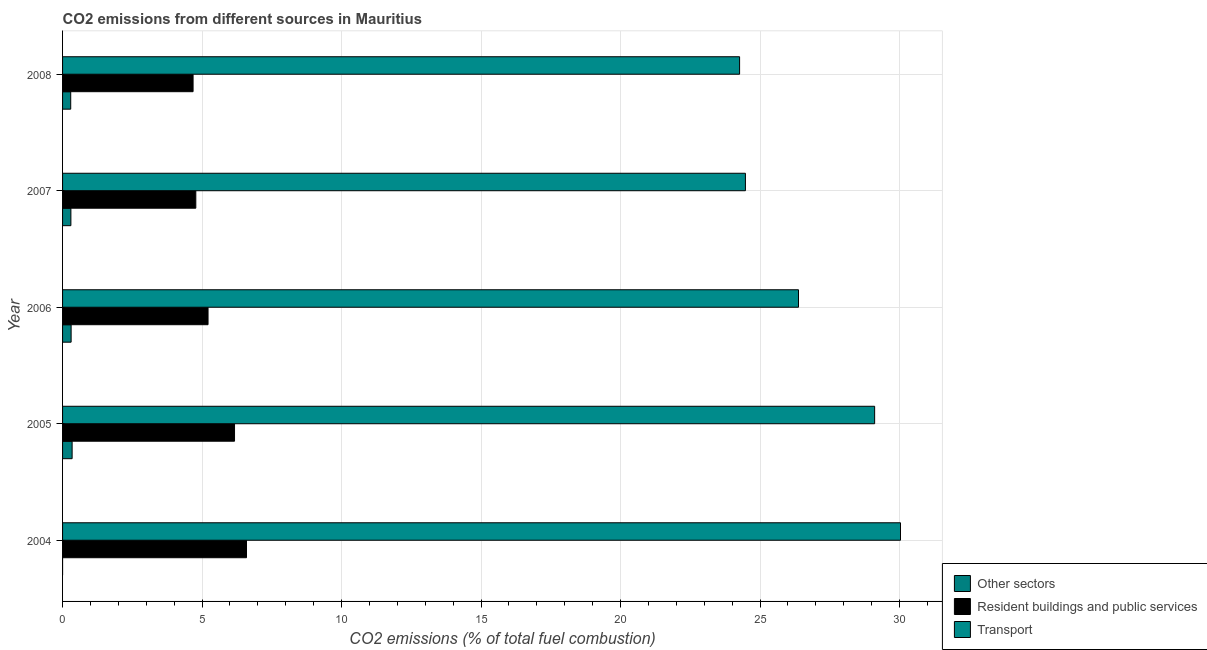How many different coloured bars are there?
Ensure brevity in your answer.  3. Are the number of bars per tick equal to the number of legend labels?
Ensure brevity in your answer.  No. Are the number of bars on each tick of the Y-axis equal?
Offer a very short reply. No. What is the label of the 2nd group of bars from the top?
Keep it short and to the point. 2007. What is the percentage of co2 emissions from transport in 2005?
Your answer should be very brief. 29.11. Across all years, what is the maximum percentage of co2 emissions from transport?
Provide a succinct answer. 30.04. What is the total percentage of co2 emissions from other sectors in the graph?
Your answer should be compact. 1.24. What is the difference between the percentage of co2 emissions from other sectors in 2007 and that in 2008?
Provide a short and direct response. 0.01. What is the difference between the percentage of co2 emissions from resident buildings and public services in 2006 and the percentage of co2 emissions from other sectors in 2005?
Your answer should be compact. 4.87. What is the average percentage of co2 emissions from other sectors per year?
Ensure brevity in your answer.  0.25. In the year 2005, what is the difference between the percentage of co2 emissions from resident buildings and public services and percentage of co2 emissions from other sectors?
Provide a succinct answer. 5.82. In how many years, is the percentage of co2 emissions from other sectors greater than 30 %?
Offer a very short reply. 0. What is the ratio of the percentage of co2 emissions from resident buildings and public services in 2004 to that in 2006?
Your answer should be very brief. 1.26. Is the difference between the percentage of co2 emissions from resident buildings and public services in 2006 and 2008 greater than the difference between the percentage of co2 emissions from transport in 2006 and 2008?
Your answer should be compact. No. What is the difference between the highest and the second highest percentage of co2 emissions from resident buildings and public services?
Offer a very short reply. 0.43. What is the difference between the highest and the lowest percentage of co2 emissions from resident buildings and public services?
Provide a short and direct response. 1.92. In how many years, is the percentage of co2 emissions from transport greater than the average percentage of co2 emissions from transport taken over all years?
Keep it short and to the point. 2. Is it the case that in every year, the sum of the percentage of co2 emissions from other sectors and percentage of co2 emissions from resident buildings and public services is greater than the percentage of co2 emissions from transport?
Make the answer very short. No. Are all the bars in the graph horizontal?
Provide a succinct answer. Yes. What is the difference between two consecutive major ticks on the X-axis?
Provide a short and direct response. 5. Where does the legend appear in the graph?
Provide a short and direct response. Bottom right. How many legend labels are there?
Your answer should be very brief. 3. What is the title of the graph?
Make the answer very short. CO2 emissions from different sources in Mauritius. Does "Hydroelectric sources" appear as one of the legend labels in the graph?
Provide a succinct answer. No. What is the label or title of the X-axis?
Provide a short and direct response. CO2 emissions (% of total fuel combustion). What is the CO2 emissions (% of total fuel combustion) in Resident buildings and public services in 2004?
Give a very brief answer. 6.59. What is the CO2 emissions (% of total fuel combustion) of Transport in 2004?
Your answer should be compact. 30.04. What is the CO2 emissions (% of total fuel combustion) of Other sectors in 2005?
Your answer should be very brief. 0.34. What is the CO2 emissions (% of total fuel combustion) of Resident buildings and public services in 2005?
Provide a short and direct response. 6.16. What is the CO2 emissions (% of total fuel combustion) of Transport in 2005?
Make the answer very short. 29.11. What is the CO2 emissions (% of total fuel combustion) of Other sectors in 2006?
Ensure brevity in your answer.  0.31. What is the CO2 emissions (% of total fuel combustion) in Resident buildings and public services in 2006?
Your response must be concise. 5.21. What is the CO2 emissions (% of total fuel combustion) of Transport in 2006?
Ensure brevity in your answer.  26.38. What is the CO2 emissions (% of total fuel combustion) of Other sectors in 2007?
Provide a short and direct response. 0.3. What is the CO2 emissions (% of total fuel combustion) of Resident buildings and public services in 2007?
Your answer should be very brief. 4.78. What is the CO2 emissions (% of total fuel combustion) in Transport in 2007?
Your answer should be compact. 24.48. What is the CO2 emissions (% of total fuel combustion) of Other sectors in 2008?
Ensure brevity in your answer.  0.29. What is the CO2 emissions (% of total fuel combustion) of Resident buildings and public services in 2008?
Your response must be concise. 4.68. What is the CO2 emissions (% of total fuel combustion) of Transport in 2008?
Make the answer very short. 24.27. Across all years, what is the maximum CO2 emissions (% of total fuel combustion) in Other sectors?
Your answer should be very brief. 0.34. Across all years, what is the maximum CO2 emissions (% of total fuel combustion) in Resident buildings and public services?
Make the answer very short. 6.59. Across all years, what is the maximum CO2 emissions (% of total fuel combustion) in Transport?
Offer a terse response. 30.04. Across all years, what is the minimum CO2 emissions (% of total fuel combustion) in Resident buildings and public services?
Your answer should be compact. 4.68. Across all years, what is the minimum CO2 emissions (% of total fuel combustion) of Transport?
Keep it short and to the point. 24.27. What is the total CO2 emissions (% of total fuel combustion) of Other sectors in the graph?
Offer a terse response. 1.24. What is the total CO2 emissions (% of total fuel combustion) of Resident buildings and public services in the graph?
Your answer should be very brief. 27.43. What is the total CO2 emissions (% of total fuel combustion) in Transport in the graph?
Provide a succinct answer. 134.27. What is the difference between the CO2 emissions (% of total fuel combustion) of Resident buildings and public services in 2004 and that in 2005?
Provide a succinct answer. 0.43. What is the difference between the CO2 emissions (% of total fuel combustion) in Transport in 2004 and that in 2005?
Provide a succinct answer. 0.93. What is the difference between the CO2 emissions (% of total fuel combustion) in Resident buildings and public services in 2004 and that in 2006?
Provide a succinct answer. 1.38. What is the difference between the CO2 emissions (% of total fuel combustion) of Transport in 2004 and that in 2006?
Provide a short and direct response. 3.66. What is the difference between the CO2 emissions (% of total fuel combustion) of Resident buildings and public services in 2004 and that in 2007?
Provide a short and direct response. 1.82. What is the difference between the CO2 emissions (% of total fuel combustion) of Transport in 2004 and that in 2007?
Give a very brief answer. 5.56. What is the difference between the CO2 emissions (% of total fuel combustion) in Resident buildings and public services in 2004 and that in 2008?
Offer a very short reply. 1.92. What is the difference between the CO2 emissions (% of total fuel combustion) of Transport in 2004 and that in 2008?
Keep it short and to the point. 5.77. What is the difference between the CO2 emissions (% of total fuel combustion) of Other sectors in 2005 and that in 2006?
Make the answer very short. 0.04. What is the difference between the CO2 emissions (% of total fuel combustion) in Resident buildings and public services in 2005 and that in 2006?
Make the answer very short. 0.95. What is the difference between the CO2 emissions (% of total fuel combustion) of Transport in 2005 and that in 2006?
Your response must be concise. 2.73. What is the difference between the CO2 emissions (% of total fuel combustion) of Other sectors in 2005 and that in 2007?
Your answer should be compact. 0.04. What is the difference between the CO2 emissions (% of total fuel combustion) in Resident buildings and public services in 2005 and that in 2007?
Ensure brevity in your answer.  1.39. What is the difference between the CO2 emissions (% of total fuel combustion) of Transport in 2005 and that in 2007?
Ensure brevity in your answer.  4.63. What is the difference between the CO2 emissions (% of total fuel combustion) in Other sectors in 2005 and that in 2008?
Offer a terse response. 0.05. What is the difference between the CO2 emissions (% of total fuel combustion) of Resident buildings and public services in 2005 and that in 2008?
Give a very brief answer. 1.49. What is the difference between the CO2 emissions (% of total fuel combustion) in Transport in 2005 and that in 2008?
Provide a succinct answer. 4.84. What is the difference between the CO2 emissions (% of total fuel combustion) in Other sectors in 2006 and that in 2007?
Keep it short and to the point. 0.01. What is the difference between the CO2 emissions (% of total fuel combustion) of Resident buildings and public services in 2006 and that in 2007?
Offer a very short reply. 0.44. What is the difference between the CO2 emissions (% of total fuel combustion) of Transport in 2006 and that in 2007?
Offer a very short reply. 1.9. What is the difference between the CO2 emissions (% of total fuel combustion) in Other sectors in 2006 and that in 2008?
Ensure brevity in your answer.  0.01. What is the difference between the CO2 emissions (% of total fuel combustion) of Resident buildings and public services in 2006 and that in 2008?
Your answer should be very brief. 0.54. What is the difference between the CO2 emissions (% of total fuel combustion) in Transport in 2006 and that in 2008?
Give a very brief answer. 2.11. What is the difference between the CO2 emissions (% of total fuel combustion) of Other sectors in 2007 and that in 2008?
Provide a short and direct response. 0.01. What is the difference between the CO2 emissions (% of total fuel combustion) in Resident buildings and public services in 2007 and that in 2008?
Offer a very short reply. 0.1. What is the difference between the CO2 emissions (% of total fuel combustion) of Transport in 2007 and that in 2008?
Offer a very short reply. 0.21. What is the difference between the CO2 emissions (% of total fuel combustion) in Resident buildings and public services in 2004 and the CO2 emissions (% of total fuel combustion) in Transport in 2005?
Ensure brevity in your answer.  -22.52. What is the difference between the CO2 emissions (% of total fuel combustion) of Resident buildings and public services in 2004 and the CO2 emissions (% of total fuel combustion) of Transport in 2006?
Offer a terse response. -19.79. What is the difference between the CO2 emissions (% of total fuel combustion) of Resident buildings and public services in 2004 and the CO2 emissions (% of total fuel combustion) of Transport in 2007?
Your answer should be compact. -17.88. What is the difference between the CO2 emissions (% of total fuel combustion) of Resident buildings and public services in 2004 and the CO2 emissions (% of total fuel combustion) of Transport in 2008?
Offer a terse response. -17.68. What is the difference between the CO2 emissions (% of total fuel combustion) in Other sectors in 2005 and the CO2 emissions (% of total fuel combustion) in Resident buildings and public services in 2006?
Make the answer very short. -4.87. What is the difference between the CO2 emissions (% of total fuel combustion) of Other sectors in 2005 and the CO2 emissions (% of total fuel combustion) of Transport in 2006?
Offer a terse response. -26.04. What is the difference between the CO2 emissions (% of total fuel combustion) of Resident buildings and public services in 2005 and the CO2 emissions (% of total fuel combustion) of Transport in 2006?
Provide a succinct answer. -20.22. What is the difference between the CO2 emissions (% of total fuel combustion) in Other sectors in 2005 and the CO2 emissions (% of total fuel combustion) in Resident buildings and public services in 2007?
Ensure brevity in your answer.  -4.43. What is the difference between the CO2 emissions (% of total fuel combustion) in Other sectors in 2005 and the CO2 emissions (% of total fuel combustion) in Transport in 2007?
Keep it short and to the point. -24.14. What is the difference between the CO2 emissions (% of total fuel combustion) of Resident buildings and public services in 2005 and the CO2 emissions (% of total fuel combustion) of Transport in 2007?
Offer a terse response. -18.31. What is the difference between the CO2 emissions (% of total fuel combustion) of Other sectors in 2005 and the CO2 emissions (% of total fuel combustion) of Resident buildings and public services in 2008?
Ensure brevity in your answer.  -4.34. What is the difference between the CO2 emissions (% of total fuel combustion) of Other sectors in 2005 and the CO2 emissions (% of total fuel combustion) of Transport in 2008?
Make the answer very short. -23.93. What is the difference between the CO2 emissions (% of total fuel combustion) in Resident buildings and public services in 2005 and the CO2 emissions (% of total fuel combustion) in Transport in 2008?
Provide a short and direct response. -18.1. What is the difference between the CO2 emissions (% of total fuel combustion) in Other sectors in 2006 and the CO2 emissions (% of total fuel combustion) in Resident buildings and public services in 2007?
Provide a succinct answer. -4.47. What is the difference between the CO2 emissions (% of total fuel combustion) of Other sectors in 2006 and the CO2 emissions (% of total fuel combustion) of Transport in 2007?
Make the answer very short. -24.17. What is the difference between the CO2 emissions (% of total fuel combustion) in Resident buildings and public services in 2006 and the CO2 emissions (% of total fuel combustion) in Transport in 2007?
Give a very brief answer. -19.26. What is the difference between the CO2 emissions (% of total fuel combustion) in Other sectors in 2006 and the CO2 emissions (% of total fuel combustion) in Resident buildings and public services in 2008?
Your answer should be compact. -4.37. What is the difference between the CO2 emissions (% of total fuel combustion) in Other sectors in 2006 and the CO2 emissions (% of total fuel combustion) in Transport in 2008?
Keep it short and to the point. -23.96. What is the difference between the CO2 emissions (% of total fuel combustion) in Resident buildings and public services in 2006 and the CO2 emissions (% of total fuel combustion) in Transport in 2008?
Offer a very short reply. -19.05. What is the difference between the CO2 emissions (% of total fuel combustion) of Other sectors in 2007 and the CO2 emissions (% of total fuel combustion) of Resident buildings and public services in 2008?
Offer a terse response. -4.38. What is the difference between the CO2 emissions (% of total fuel combustion) in Other sectors in 2007 and the CO2 emissions (% of total fuel combustion) in Transport in 2008?
Keep it short and to the point. -23.97. What is the difference between the CO2 emissions (% of total fuel combustion) in Resident buildings and public services in 2007 and the CO2 emissions (% of total fuel combustion) in Transport in 2008?
Give a very brief answer. -19.49. What is the average CO2 emissions (% of total fuel combustion) of Other sectors per year?
Your response must be concise. 0.25. What is the average CO2 emissions (% of total fuel combustion) of Resident buildings and public services per year?
Your answer should be compact. 5.49. What is the average CO2 emissions (% of total fuel combustion) of Transport per year?
Give a very brief answer. 26.85. In the year 2004, what is the difference between the CO2 emissions (% of total fuel combustion) in Resident buildings and public services and CO2 emissions (% of total fuel combustion) in Transport?
Give a very brief answer. -23.44. In the year 2005, what is the difference between the CO2 emissions (% of total fuel combustion) of Other sectors and CO2 emissions (% of total fuel combustion) of Resident buildings and public services?
Your answer should be compact. -5.82. In the year 2005, what is the difference between the CO2 emissions (% of total fuel combustion) of Other sectors and CO2 emissions (% of total fuel combustion) of Transport?
Provide a succinct answer. -28.77. In the year 2005, what is the difference between the CO2 emissions (% of total fuel combustion) in Resident buildings and public services and CO2 emissions (% of total fuel combustion) in Transport?
Your answer should be very brief. -22.95. In the year 2006, what is the difference between the CO2 emissions (% of total fuel combustion) in Other sectors and CO2 emissions (% of total fuel combustion) in Resident buildings and public services?
Ensure brevity in your answer.  -4.91. In the year 2006, what is the difference between the CO2 emissions (% of total fuel combustion) in Other sectors and CO2 emissions (% of total fuel combustion) in Transport?
Keep it short and to the point. -26.07. In the year 2006, what is the difference between the CO2 emissions (% of total fuel combustion) of Resident buildings and public services and CO2 emissions (% of total fuel combustion) of Transport?
Provide a succinct answer. -21.17. In the year 2007, what is the difference between the CO2 emissions (% of total fuel combustion) of Other sectors and CO2 emissions (% of total fuel combustion) of Resident buildings and public services?
Your response must be concise. -4.48. In the year 2007, what is the difference between the CO2 emissions (% of total fuel combustion) in Other sectors and CO2 emissions (% of total fuel combustion) in Transport?
Offer a terse response. -24.18. In the year 2007, what is the difference between the CO2 emissions (% of total fuel combustion) of Resident buildings and public services and CO2 emissions (% of total fuel combustion) of Transport?
Keep it short and to the point. -19.7. In the year 2008, what is the difference between the CO2 emissions (% of total fuel combustion) of Other sectors and CO2 emissions (% of total fuel combustion) of Resident buildings and public services?
Give a very brief answer. -4.39. In the year 2008, what is the difference between the CO2 emissions (% of total fuel combustion) in Other sectors and CO2 emissions (% of total fuel combustion) in Transport?
Provide a short and direct response. -23.98. In the year 2008, what is the difference between the CO2 emissions (% of total fuel combustion) of Resident buildings and public services and CO2 emissions (% of total fuel combustion) of Transport?
Your answer should be very brief. -19.59. What is the ratio of the CO2 emissions (% of total fuel combustion) in Resident buildings and public services in 2004 to that in 2005?
Ensure brevity in your answer.  1.07. What is the ratio of the CO2 emissions (% of total fuel combustion) of Transport in 2004 to that in 2005?
Ensure brevity in your answer.  1.03. What is the ratio of the CO2 emissions (% of total fuel combustion) of Resident buildings and public services in 2004 to that in 2006?
Offer a terse response. 1.26. What is the ratio of the CO2 emissions (% of total fuel combustion) of Transport in 2004 to that in 2006?
Offer a very short reply. 1.14. What is the ratio of the CO2 emissions (% of total fuel combustion) of Resident buildings and public services in 2004 to that in 2007?
Give a very brief answer. 1.38. What is the ratio of the CO2 emissions (% of total fuel combustion) of Transport in 2004 to that in 2007?
Provide a succinct answer. 1.23. What is the ratio of the CO2 emissions (% of total fuel combustion) of Resident buildings and public services in 2004 to that in 2008?
Ensure brevity in your answer.  1.41. What is the ratio of the CO2 emissions (% of total fuel combustion) of Transport in 2004 to that in 2008?
Your answer should be compact. 1.24. What is the ratio of the CO2 emissions (% of total fuel combustion) of Other sectors in 2005 to that in 2006?
Keep it short and to the point. 1.12. What is the ratio of the CO2 emissions (% of total fuel combustion) in Resident buildings and public services in 2005 to that in 2006?
Make the answer very short. 1.18. What is the ratio of the CO2 emissions (% of total fuel combustion) in Transport in 2005 to that in 2006?
Offer a terse response. 1.1. What is the ratio of the CO2 emissions (% of total fuel combustion) in Other sectors in 2005 to that in 2007?
Ensure brevity in your answer.  1.15. What is the ratio of the CO2 emissions (% of total fuel combustion) in Resident buildings and public services in 2005 to that in 2007?
Keep it short and to the point. 1.29. What is the ratio of the CO2 emissions (% of total fuel combustion) of Transport in 2005 to that in 2007?
Offer a very short reply. 1.19. What is the ratio of the CO2 emissions (% of total fuel combustion) of Other sectors in 2005 to that in 2008?
Give a very brief answer. 1.17. What is the ratio of the CO2 emissions (% of total fuel combustion) of Resident buildings and public services in 2005 to that in 2008?
Your answer should be compact. 1.32. What is the ratio of the CO2 emissions (% of total fuel combustion) in Transport in 2005 to that in 2008?
Provide a short and direct response. 1.2. What is the ratio of the CO2 emissions (% of total fuel combustion) of Other sectors in 2006 to that in 2007?
Your answer should be very brief. 1.03. What is the ratio of the CO2 emissions (% of total fuel combustion) of Resident buildings and public services in 2006 to that in 2007?
Your answer should be compact. 1.09. What is the ratio of the CO2 emissions (% of total fuel combustion) in Transport in 2006 to that in 2007?
Provide a short and direct response. 1.08. What is the ratio of the CO2 emissions (% of total fuel combustion) of Other sectors in 2006 to that in 2008?
Your response must be concise. 1.05. What is the ratio of the CO2 emissions (% of total fuel combustion) of Resident buildings and public services in 2006 to that in 2008?
Provide a short and direct response. 1.11. What is the ratio of the CO2 emissions (% of total fuel combustion) in Transport in 2006 to that in 2008?
Your answer should be very brief. 1.09. What is the ratio of the CO2 emissions (% of total fuel combustion) of Other sectors in 2007 to that in 2008?
Give a very brief answer. 1.02. What is the ratio of the CO2 emissions (% of total fuel combustion) of Resident buildings and public services in 2007 to that in 2008?
Make the answer very short. 1.02. What is the ratio of the CO2 emissions (% of total fuel combustion) of Transport in 2007 to that in 2008?
Offer a very short reply. 1.01. What is the difference between the highest and the second highest CO2 emissions (% of total fuel combustion) in Other sectors?
Offer a terse response. 0.04. What is the difference between the highest and the second highest CO2 emissions (% of total fuel combustion) of Resident buildings and public services?
Provide a succinct answer. 0.43. What is the difference between the highest and the second highest CO2 emissions (% of total fuel combustion) of Transport?
Your answer should be very brief. 0.93. What is the difference between the highest and the lowest CO2 emissions (% of total fuel combustion) in Other sectors?
Your answer should be very brief. 0.34. What is the difference between the highest and the lowest CO2 emissions (% of total fuel combustion) of Resident buildings and public services?
Ensure brevity in your answer.  1.92. What is the difference between the highest and the lowest CO2 emissions (% of total fuel combustion) of Transport?
Ensure brevity in your answer.  5.77. 